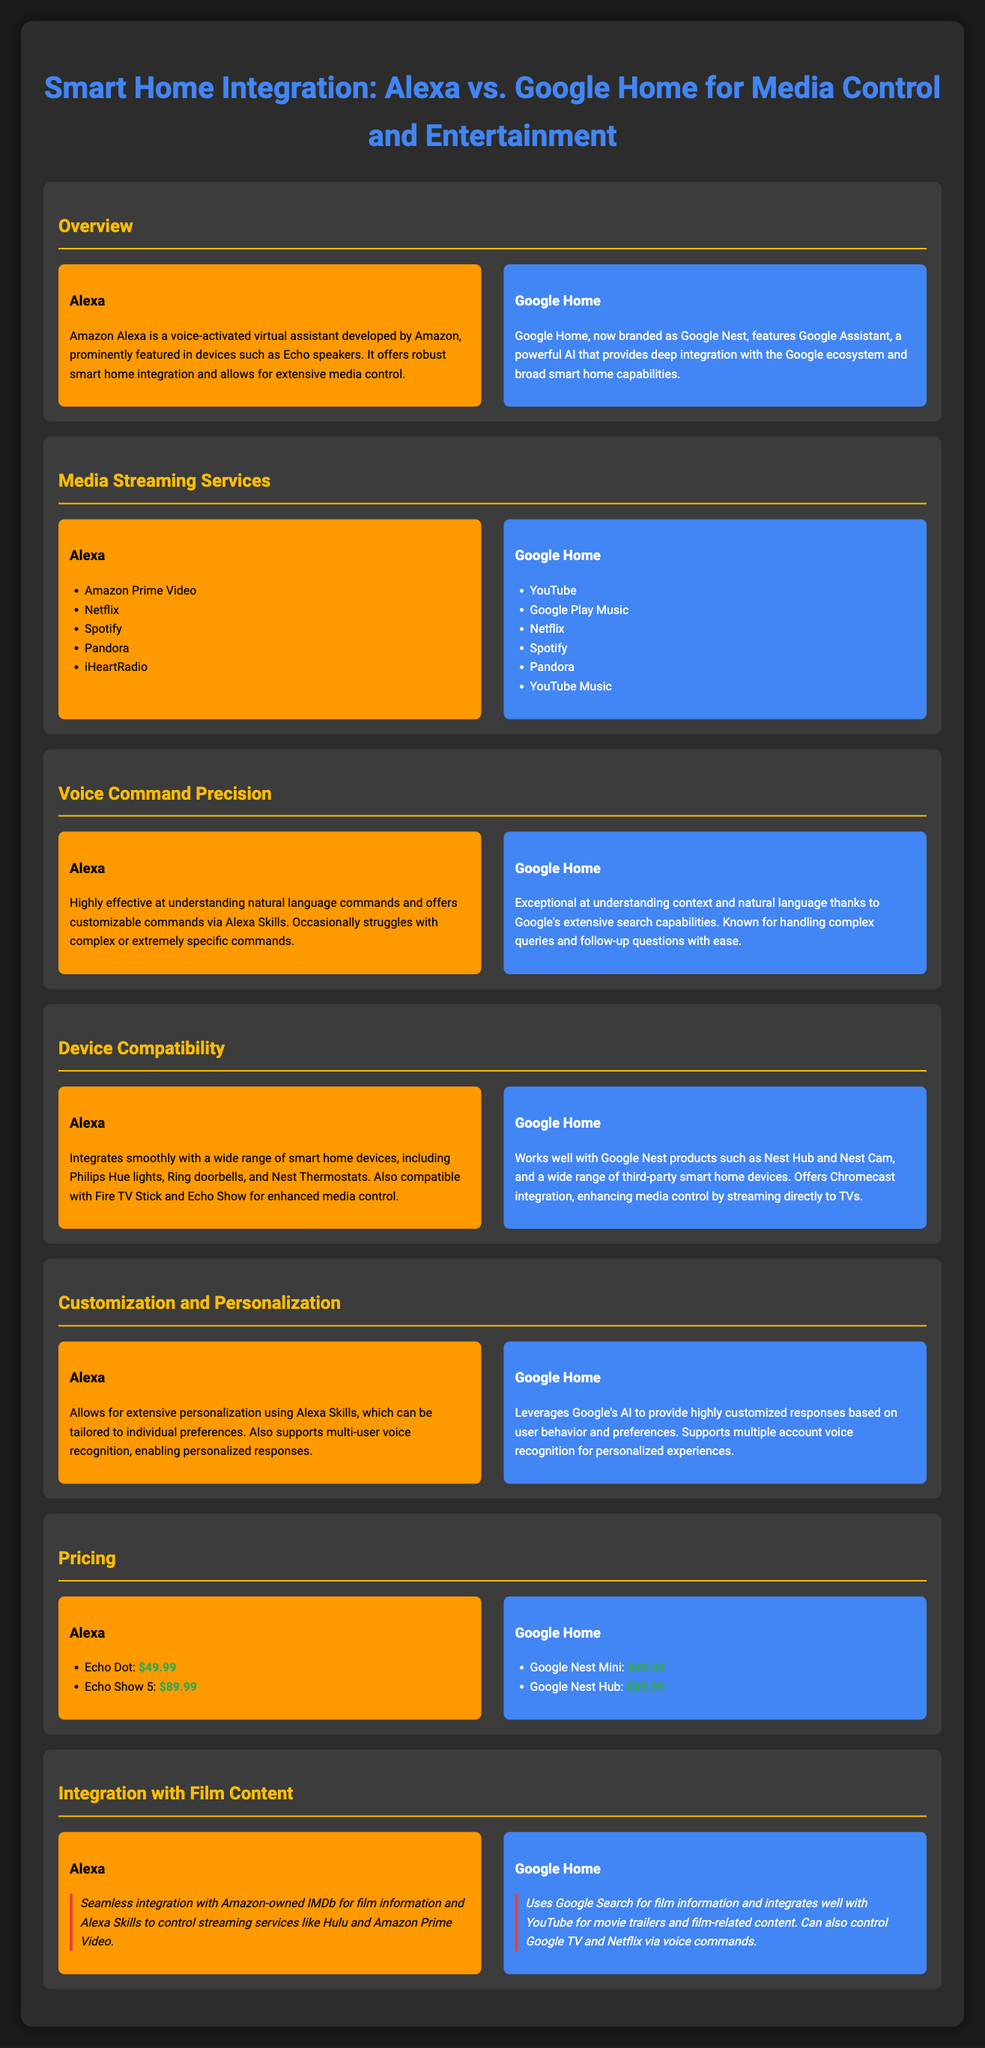What streaming service is exclusive to Alexa? The streaming service exclusive to Alexa is Amazon Prime Video, as mentioned in the Media Streaming Services section.
Answer: Amazon Prime Video Which device has exceptional voice command precision? In the Voice Command Precision section, it is indicated that Google Home has exceptional understanding of context and complex queries.
Answer: Google Home What is the price of Amazon Echo Show 5? The pricing section lists $89.99 as the price for the Amazon Echo Show 5.
Answer: $89.99 How many media streaming services does Google Home support? In the Media Streaming Services section, Google Home supports six services, including YouTube and Spotify.
Answer: Six Which smart home product integrates with Chromecast? The Device Compatibility section specifies that Google Home offers Chromecast integration for enhanced media control.
Answer: Chromecast What feature allows Alexa to provide personalized responses? Alexa offers multi-user voice recognition, as described in the Customization and Personalization section, allowing for personalized responses.
Answer: Multi-user voice recognition Which smart home device is compatible with both Alexa and Google Home? The compatibility sections list devices like Nest Thermostats for Alexa, while Google Home also works with Nest products, indicating they can both integrate with Nest devices.
Answer: Nest devices What film-related function does Alexa provide? The Integration with Film Content section explains that Alexa integrates with IMDb for film information.
Answer: IMDb Which device is priced the same for both platforms? Both Echo Dot and Google Nest Mini are priced at $49.99 in the Pricing section, indicating they share the same price.
Answer: $49.99 